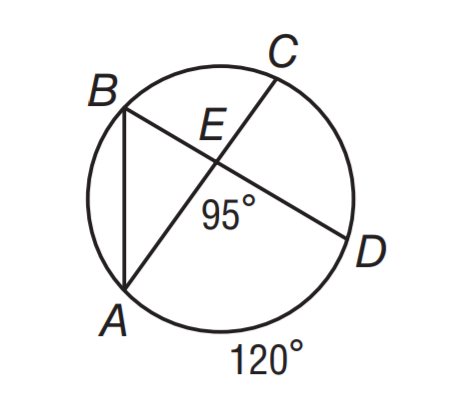Answer the mathemtical geometry problem and directly provide the correct option letter.
Question: If m \angle A E D = 95 and m \widehat A D = 120, what is m \angle B A C?
Choices: A: 30 B: 35 C: 40 D: 60 B 